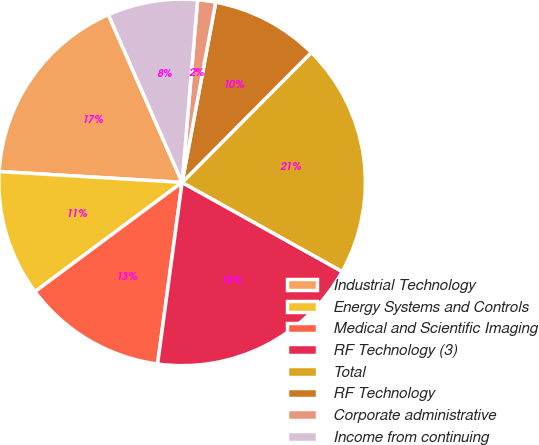<chart> <loc_0><loc_0><loc_500><loc_500><pie_chart><fcel>Industrial Technology<fcel>Energy Systems and Controls<fcel>Medical and Scientific Imaging<fcel>RF Technology (3)<fcel>Total<fcel>RF Technology<fcel>Corporate administrative<fcel>Income from continuing<nl><fcel>17.46%<fcel>11.11%<fcel>12.7%<fcel>19.05%<fcel>20.63%<fcel>9.52%<fcel>1.59%<fcel>7.94%<nl></chart> 